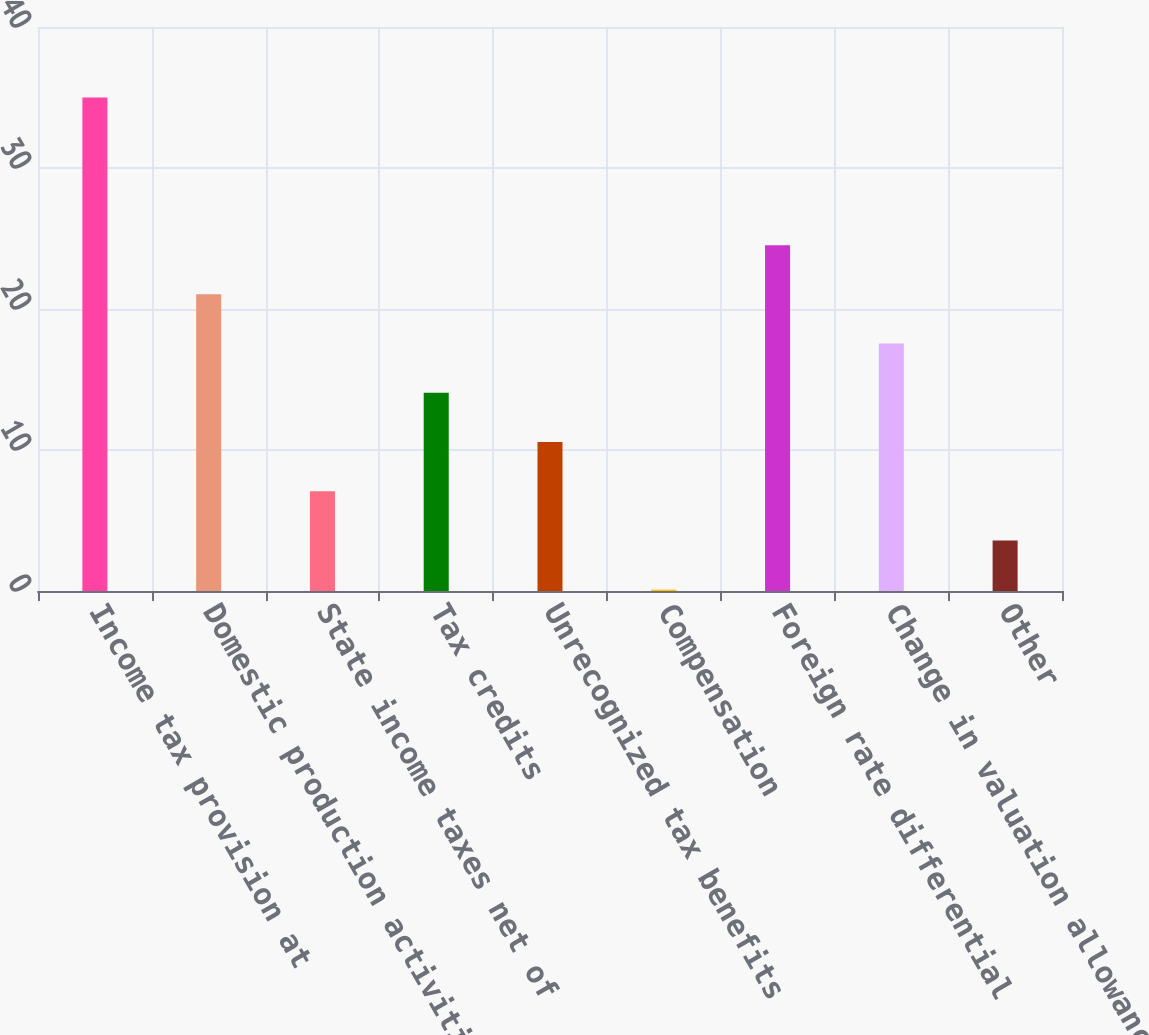Convert chart. <chart><loc_0><loc_0><loc_500><loc_500><bar_chart><fcel>Income tax provision at<fcel>Domestic production activities<fcel>State income taxes net of<fcel>Tax credits<fcel>Unrecognized tax benefits<fcel>Compensation<fcel>Foreign rate differential<fcel>Change in valuation allowance<fcel>Other<nl><fcel>35<fcel>21.04<fcel>7.08<fcel>14.06<fcel>10.57<fcel>0.1<fcel>24.53<fcel>17.55<fcel>3.59<nl></chart> 